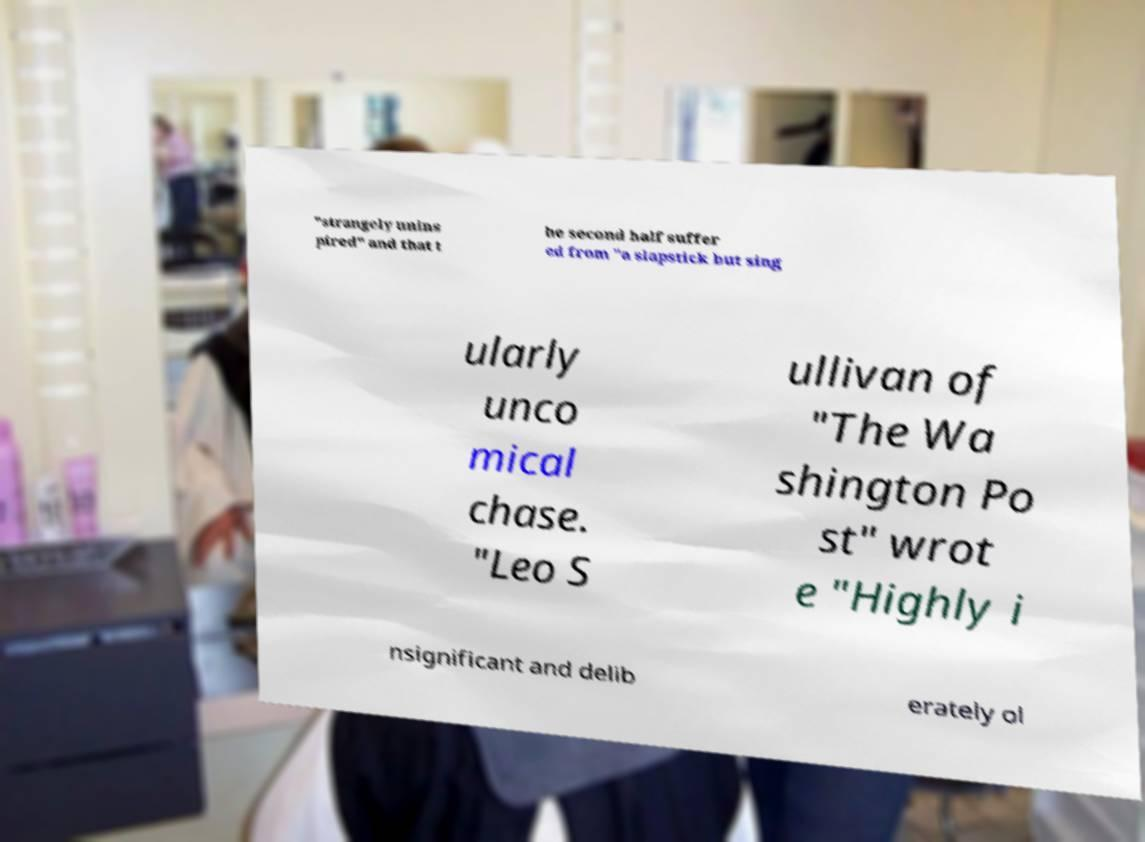Could you assist in decoding the text presented in this image and type it out clearly? "strangely unins pired" and that t he second half suffer ed from "a slapstick but sing ularly unco mical chase. "Leo S ullivan of "The Wa shington Po st" wrot e "Highly i nsignificant and delib erately ol 